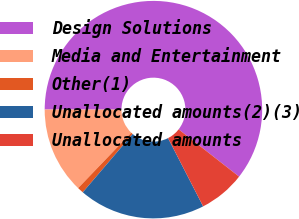Convert chart. <chart><loc_0><loc_0><loc_500><loc_500><pie_chart><fcel>Design Solutions<fcel>Media and Entertainment<fcel>Other(1)<fcel>Unallocated amounts(2)(3)<fcel>Unallocated amounts<nl><fcel>60.55%<fcel>12.84%<fcel>0.92%<fcel>18.81%<fcel>6.88%<nl></chart> 